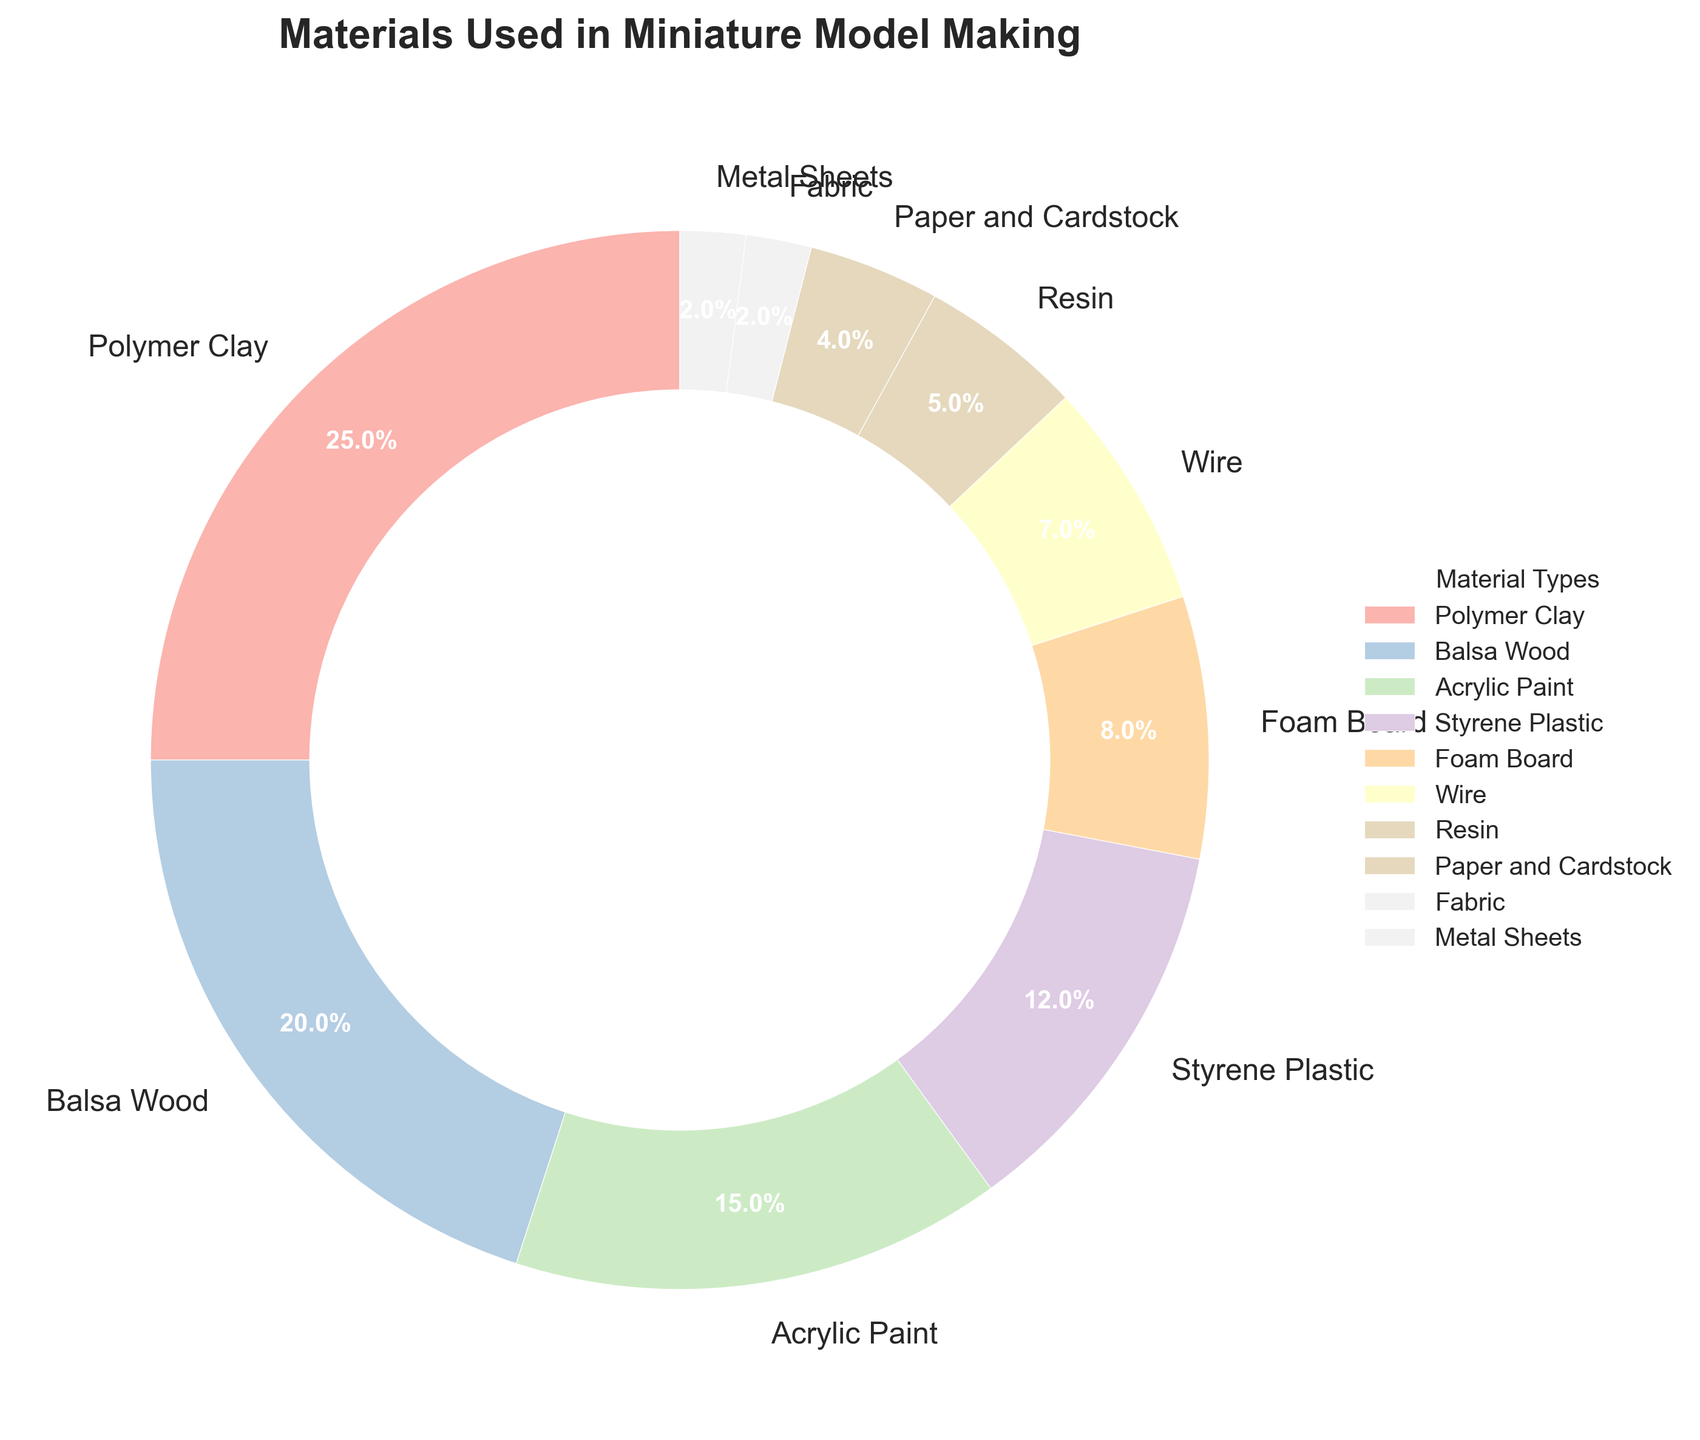what is the most used material in miniature model making? Look at the pie chart and identify the segment with the largest percentage, which is Polymer Clay at 25%.
Answer: Polymer Clay what is the difference in usage between Polymer Clay and Balsa Wood? Polymer Clay has a usage percentage of 25% and Balsa Wood has 20%. Subtract the percentage of Balsa Wood from Polymer Clay: 25% - 20% = 5%.
Answer: 5% which materials together make up 30%? Look at the chart and sum percentages until you get to 30%. Balsa Wood (20%) + Acrylic Paint (15%) = 35%, which is over 30%. Instead, Polymer Clay (25%) + Metal Sheets (2%) + Fabric (2%) + Paper and Cardstock (4%) = 33%, which also doesn't work. The correct combination is Acrylic Paint (15%) + Styrene Plastic (12%) + Metal Sheets (2%) + Fabric (2%) = 31%, which is the closest without going over.
Answer: Acrylic Paint, Styrene Plastic, Metal Sheets, Fabric which material is used exactly half as much as Styrene Plastic? Styrene Plastic has a percentage of 12%. The pie chart shows that Resin is 5%, which is not exactly half, and Foam Board at 8%, which is also not exactly half. None of the materials match this condition precisely, but Wire at 7% is the closest.
Answer: None is Resin used more or less than Foam Board? Compare the percentages of Resin (5%) and Foam Board (8%). Resin's percentage is less.
Answer: Less 